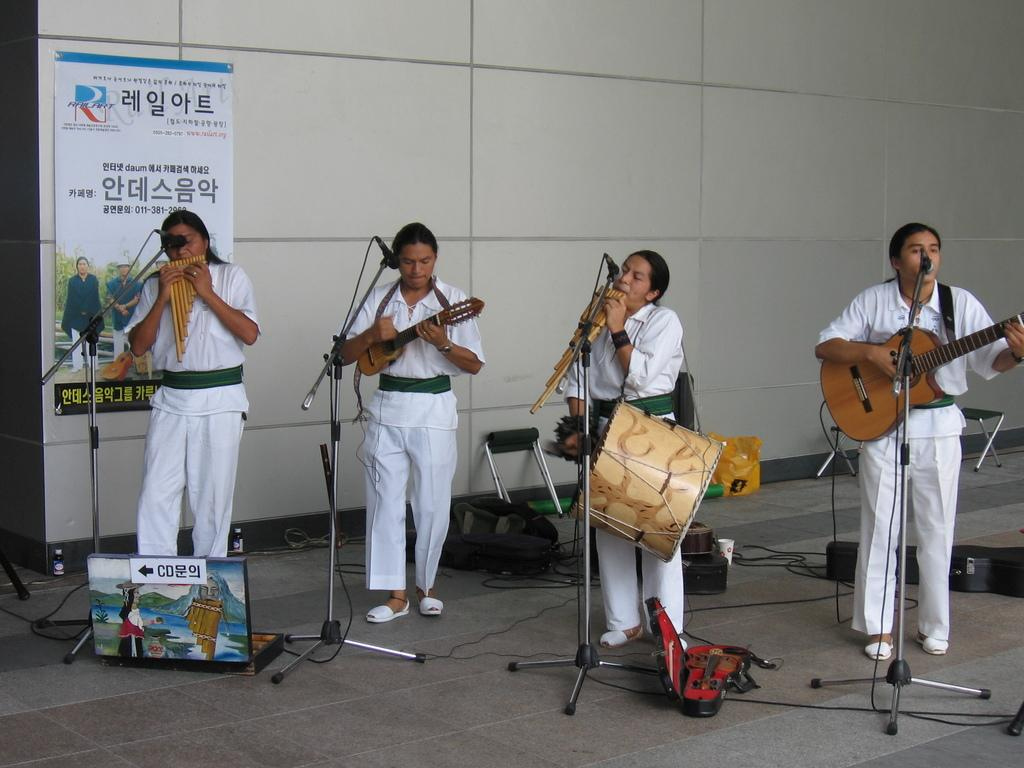What is the main activity of the people in the image? The people in the image are playing musical instruments. What can be seen behind the group of people? There is a mic in front of the people. What is attached to the wall in the image? There is a banner attached to a wall in the image. What objects related to musical instruments are present in the image? There is a box and guitar bags in the image. What book is the sister reading in the image? There is no sister or book present in the image. What celestial object can be seen shining in the image? There is no celestial object visible in the image. 